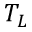<formula> <loc_0><loc_0><loc_500><loc_500>T _ { L }</formula> 